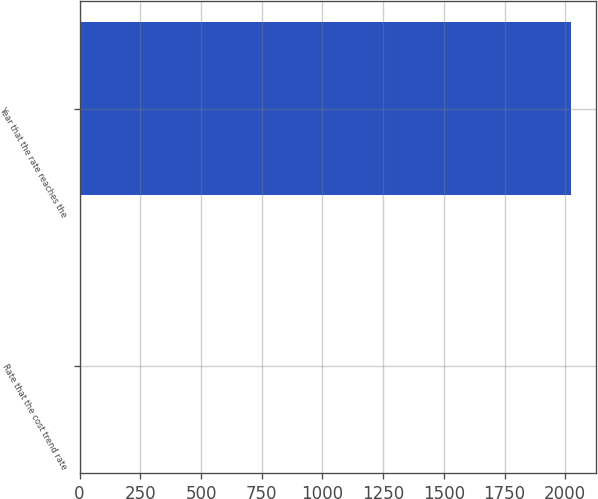<chart> <loc_0><loc_0><loc_500><loc_500><bar_chart><fcel>Rate that the cost trend rate<fcel>Year that the rate reaches the<nl><fcel>6.11<fcel>2025<nl></chart> 